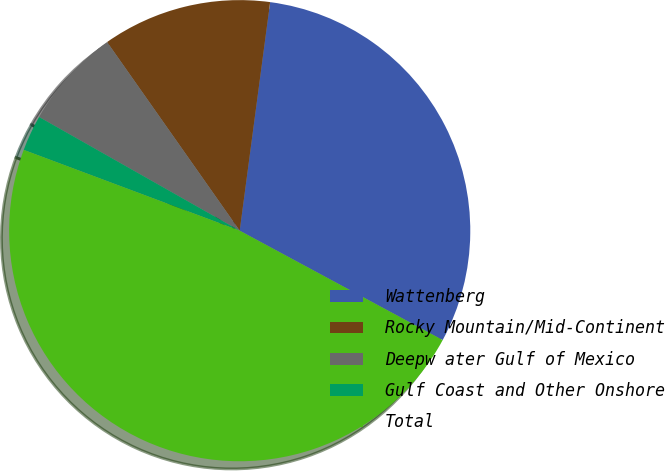Convert chart to OTSL. <chart><loc_0><loc_0><loc_500><loc_500><pie_chart><fcel>Wattenberg<fcel>Rocky Mountain/Mid-Continent<fcel>Deepw ater Gulf of Mexico<fcel>Gulf Coast and Other Onshore<fcel>Total<nl><fcel>30.76%<fcel>11.86%<fcel>7.04%<fcel>2.51%<fcel>47.83%<nl></chart> 